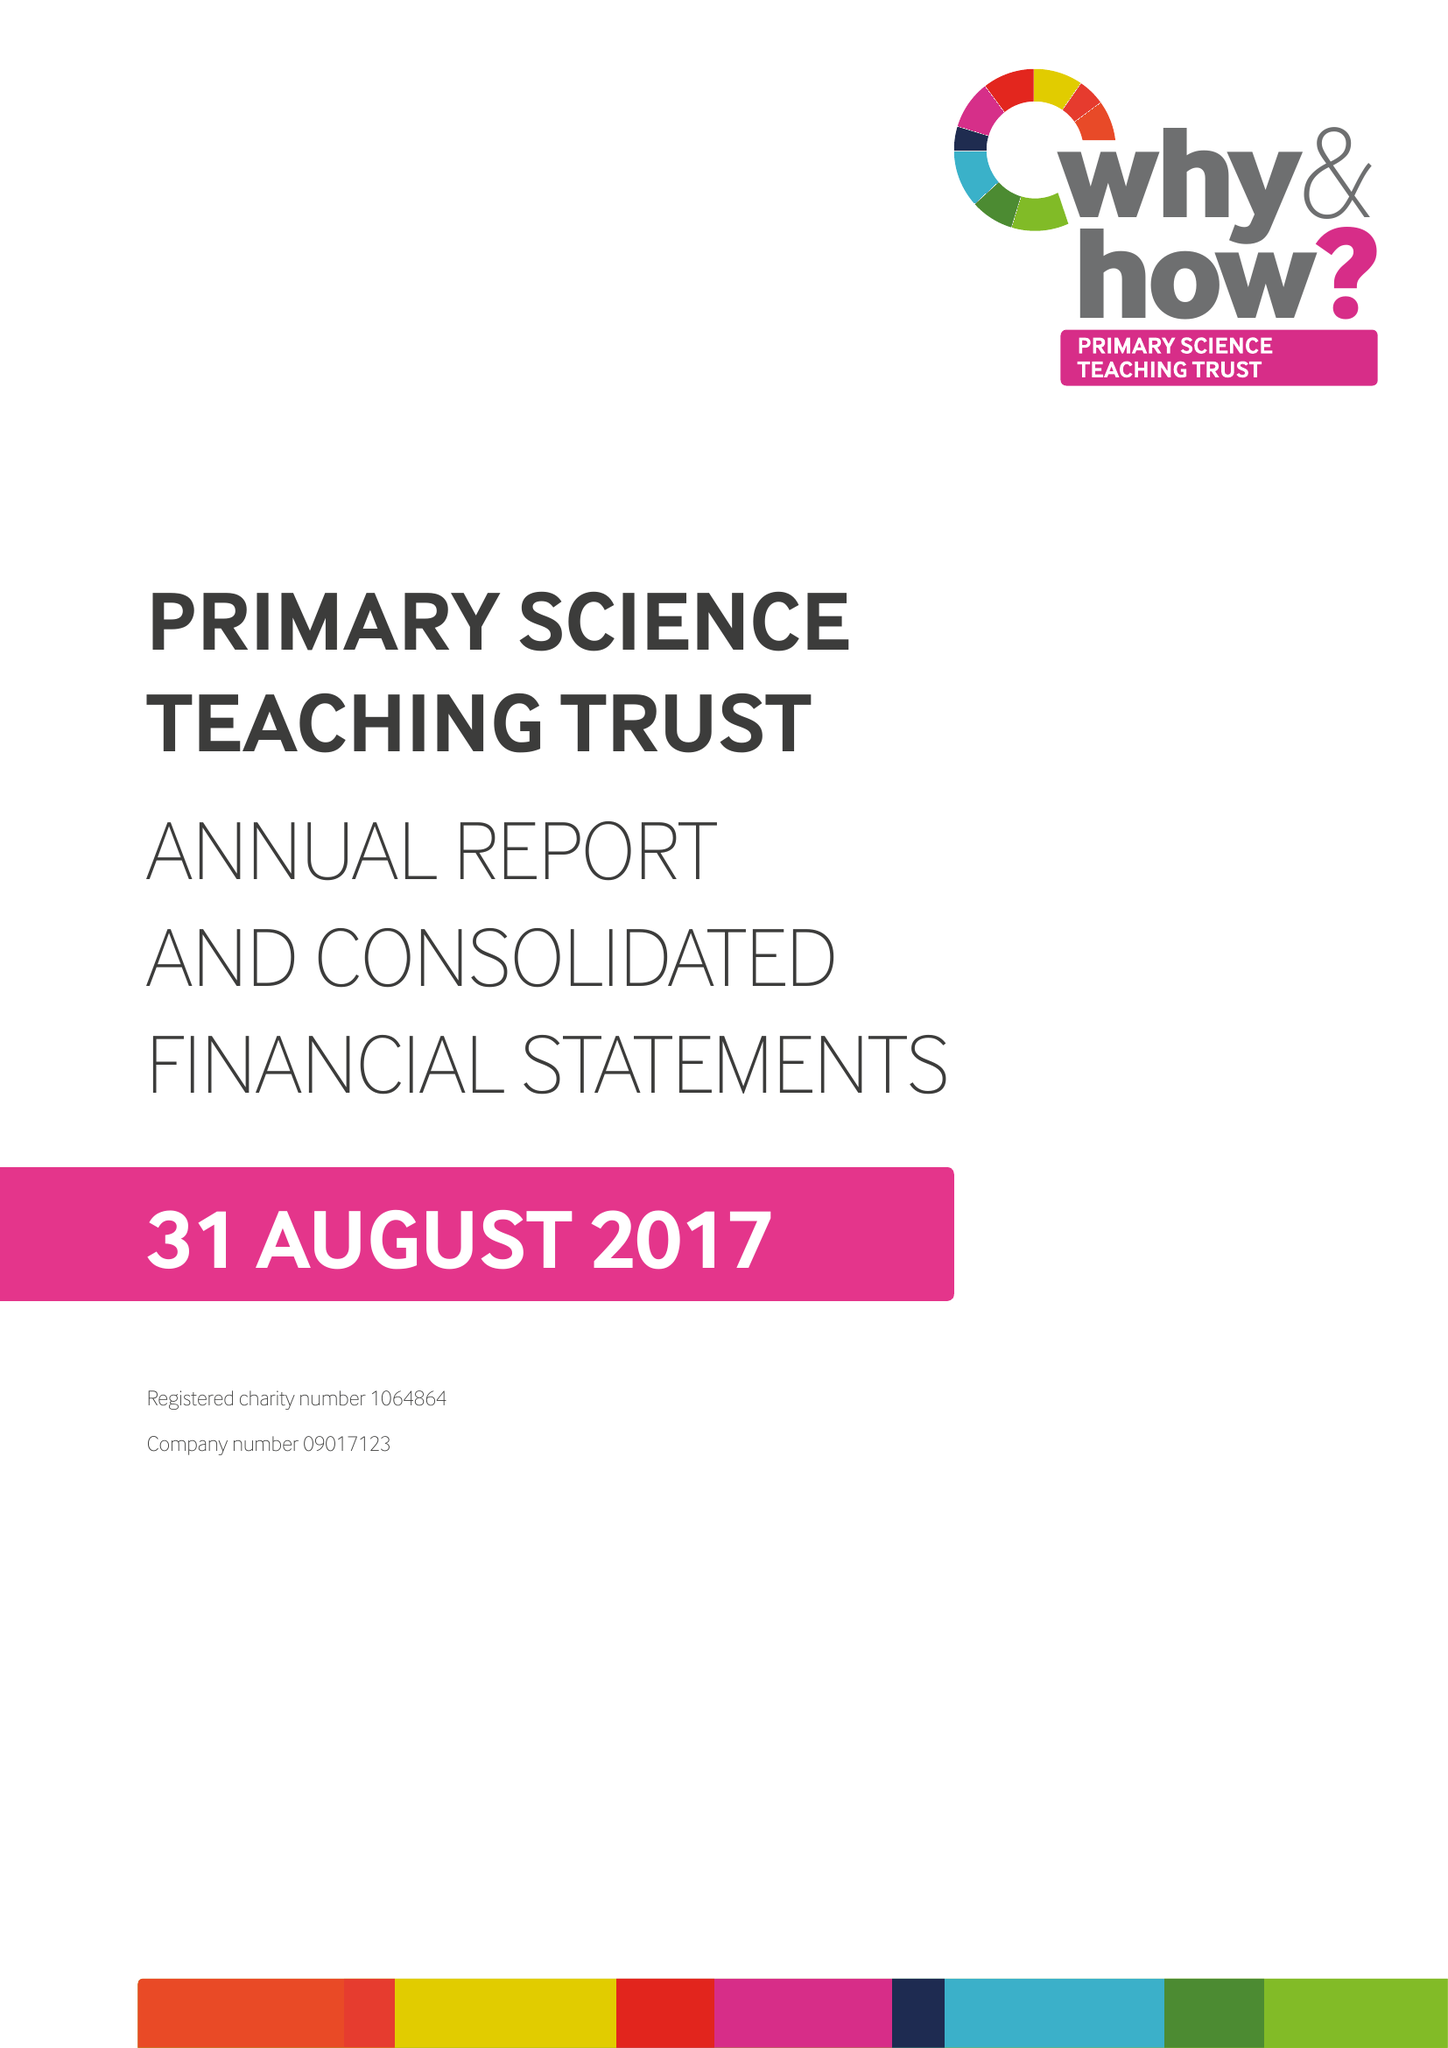What is the value for the address__post_town?
Answer the question using a single word or phrase. BRISTOL 